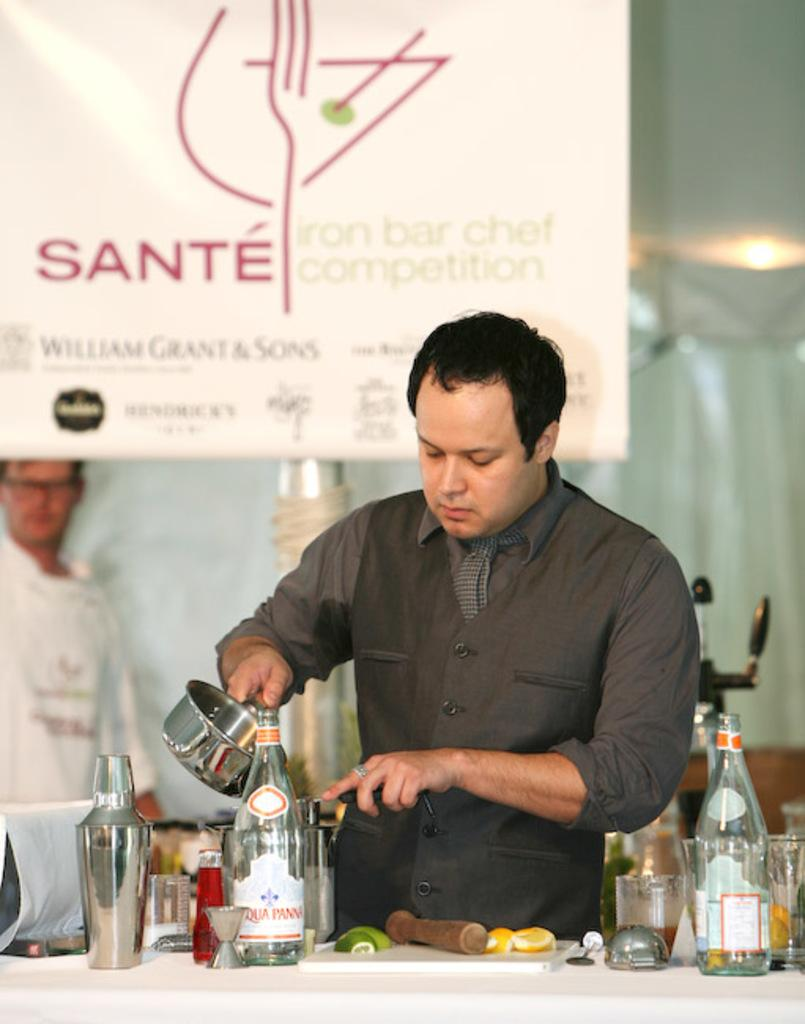Provide a one-sentence caption for the provided image. A man at the Sante bar and chef competition making a drink. 